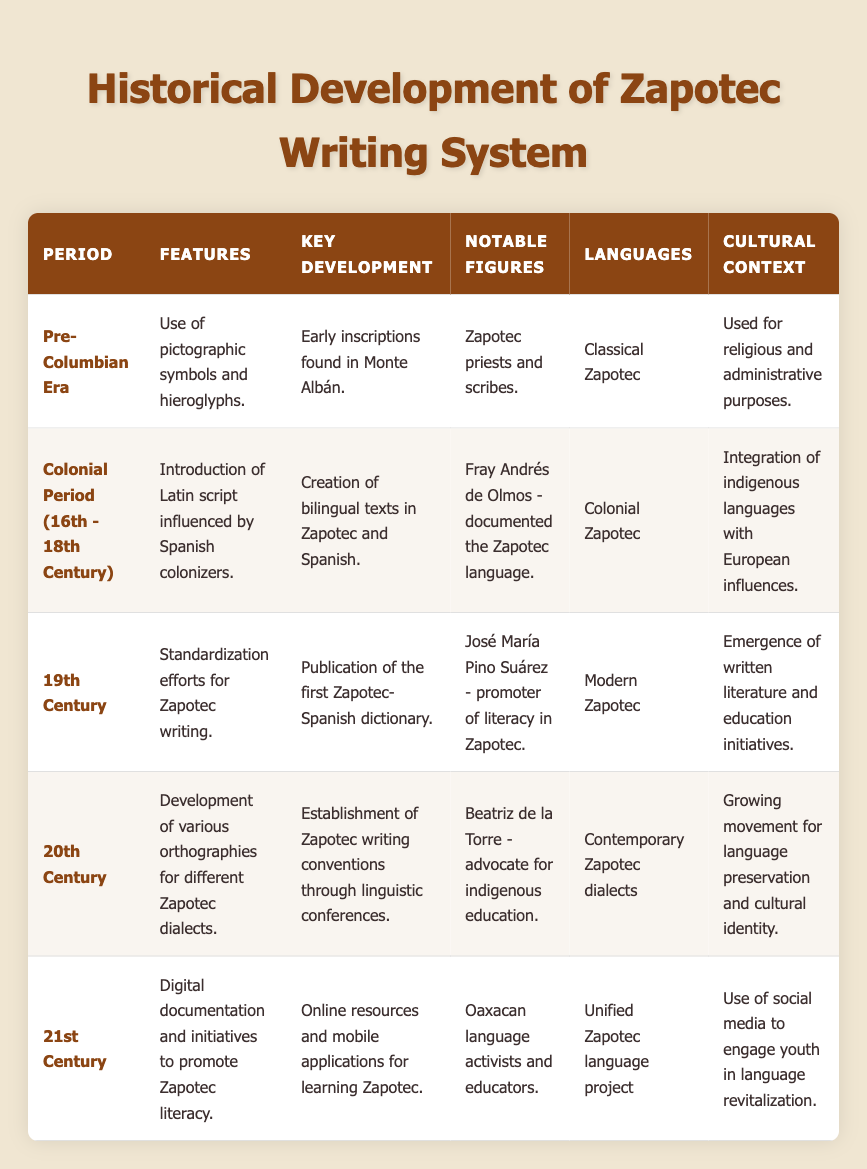What writing system was used during the Pre-Columbian Era of the Zapotec? The table indicates that during the Pre-Columbian Era, the features of the Zapotec writing system included the use of pictographic symbols and hieroglyphs. Thus, the writing system mentioned is a pictographic and hieroglyphic system.
Answer: Pictographic and hieroglyphic system Who documented the Zapotec language during the Colonial Period? According to the table, Fray Andrés de Olmos is noted as a significant figure who documented the Zapotec language during the Colonial period.
Answer: Fray Andrés de Olmos What was a key development in the 19th Century for the Zapotec writing system? The table states that a key development in the 19th Century was the publication of the first Zapotec-Spanish dictionary.
Answer: Publication of the first Zapotec-Spanish dictionary True or False: The 21st Century saw a focus on oral traditions in the Zapotec writing system. The table reveals that the 21st Century primarily involved digital documentation and initiatives to promote Zapotec literacy, indicating a focus on written forms rather than oral traditions. Thus, the statement is false.
Answer: False What notable figures were advocates for the preservation and education of the Zapotec language in the 20th Century? The table provides information that Beatriz de la Torre was an advocate for indigenous education, which relates to the preservation of the Zapotec language during the 20th Century.
Answer: Beatriz de la Torre Compare the cultural context between the Colonial Period and the 20th Century. The Colonial Period focused on the integration of indigenous languages with European influences, while the 20th Century showed a growing movement for language preservation and cultural identity. Thus, the two periods have differing emphases on integration versus preservation.
Answer: Integration in Colonial Period, preservation in 20th Century What features characterized the Zapotec writing system in the 20th Century? The table indicates that during the 20th Century, the Zapotec writing system featured the development of various orthographies for different dialects. This highlights the diversification in writing conventions during this period.
Answer: Development of various orthographies During which period were online resources introduced for learning Zapotec? The data clearly states that the 21st Century marked the introduction of online resources and mobile applications for learning Zapotec. This was a significant development during this time.
Answer: 21st Century Identify the language used in the Pre-Columbian Era of the Zapotec writing system. According to the table, the language associated with the Pre-Columbian Era is listed as Classical Zapotec, which relates to the writing system of that time.
Answer: Classical Zapotec 